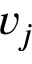<formula> <loc_0><loc_0><loc_500><loc_500>v _ { j }</formula> 